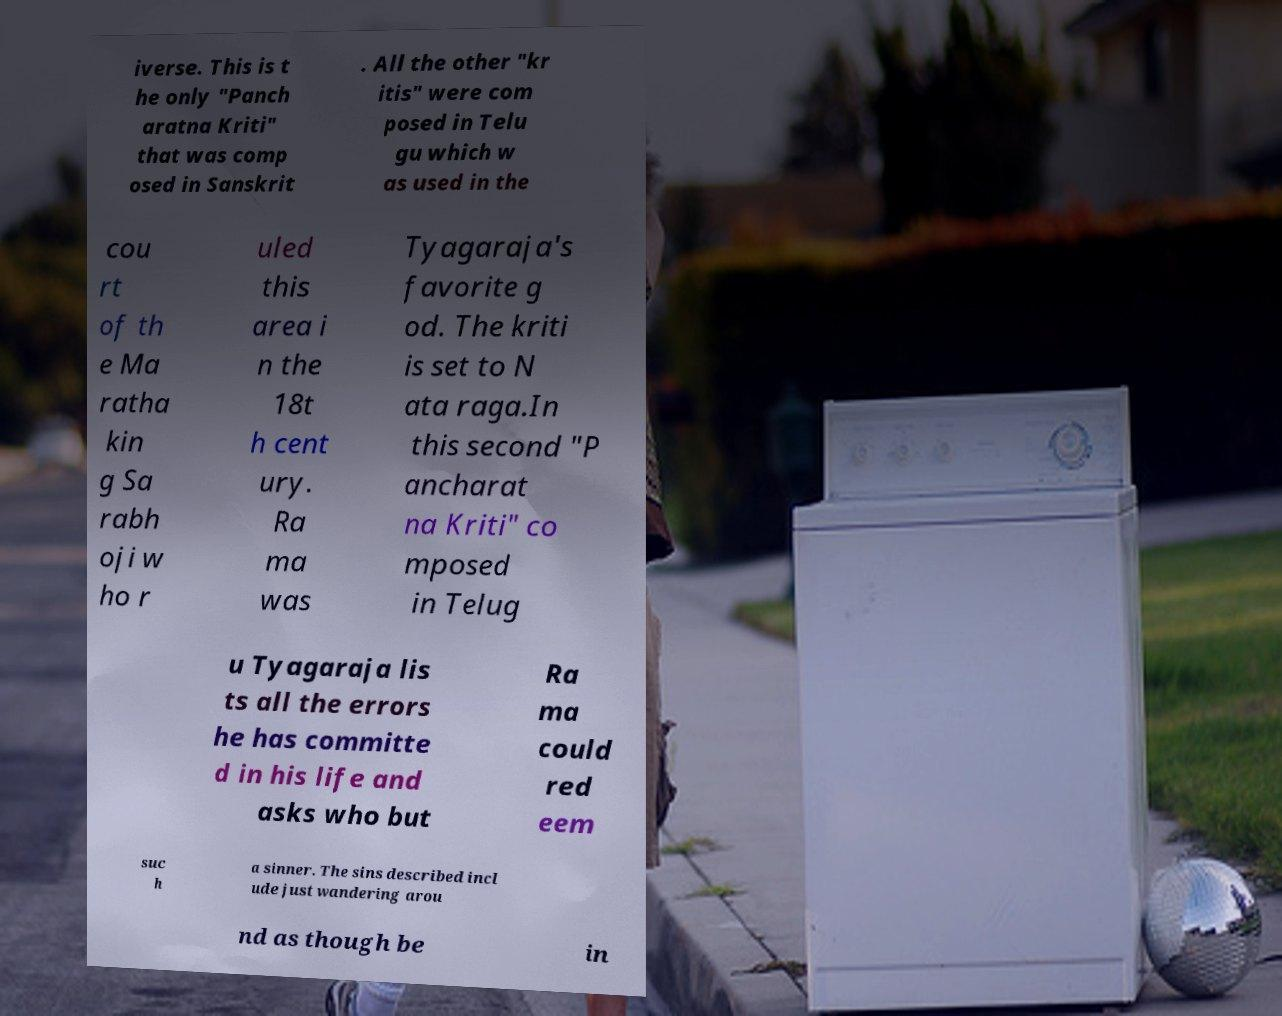What messages or text are displayed in this image? I need them in a readable, typed format. iverse. This is t he only "Panch aratna Kriti" that was comp osed in Sanskrit . All the other "kr itis" were com posed in Telu gu which w as used in the cou rt of th e Ma ratha kin g Sa rabh oji w ho r uled this area i n the 18t h cent ury. Ra ma was Tyagaraja's favorite g od. The kriti is set to N ata raga.In this second "P ancharat na Kriti" co mposed in Telug u Tyagaraja lis ts all the errors he has committe d in his life and asks who but Ra ma could red eem suc h a sinner. The sins described incl ude just wandering arou nd as though be in 